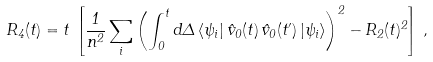Convert formula to latex. <formula><loc_0><loc_0><loc_500><loc_500>R _ { 4 } ( t ) = t \, \left [ \frac { 1 } { n ^ { 2 } } \sum _ { i } \left ( \int _ { 0 } ^ { t } d \Delta \, \langle \psi _ { i } | \, \hat { v } _ { 0 } ( t ) \, \hat { v } _ { 0 } ( t ^ { \prime } ) \, | \psi _ { i } \rangle \right ) ^ { 2 } - R _ { 2 } ( t ) ^ { 2 } \right ] \, ,</formula> 